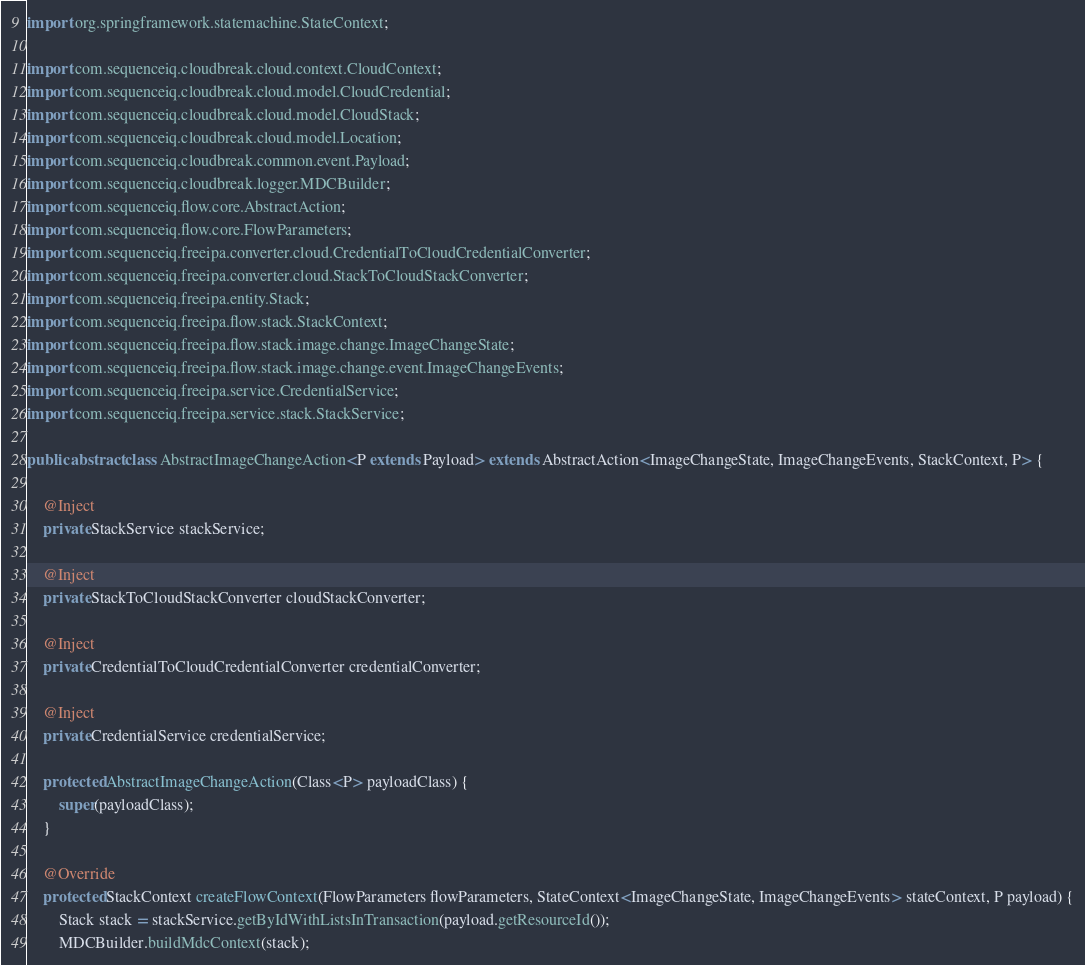<code> <loc_0><loc_0><loc_500><loc_500><_Java_>
import org.springframework.statemachine.StateContext;

import com.sequenceiq.cloudbreak.cloud.context.CloudContext;
import com.sequenceiq.cloudbreak.cloud.model.CloudCredential;
import com.sequenceiq.cloudbreak.cloud.model.CloudStack;
import com.sequenceiq.cloudbreak.cloud.model.Location;
import com.sequenceiq.cloudbreak.common.event.Payload;
import com.sequenceiq.cloudbreak.logger.MDCBuilder;
import com.sequenceiq.flow.core.AbstractAction;
import com.sequenceiq.flow.core.FlowParameters;
import com.sequenceiq.freeipa.converter.cloud.CredentialToCloudCredentialConverter;
import com.sequenceiq.freeipa.converter.cloud.StackToCloudStackConverter;
import com.sequenceiq.freeipa.entity.Stack;
import com.sequenceiq.freeipa.flow.stack.StackContext;
import com.sequenceiq.freeipa.flow.stack.image.change.ImageChangeState;
import com.sequenceiq.freeipa.flow.stack.image.change.event.ImageChangeEvents;
import com.sequenceiq.freeipa.service.CredentialService;
import com.sequenceiq.freeipa.service.stack.StackService;

public abstract class AbstractImageChangeAction<P extends Payload> extends AbstractAction<ImageChangeState, ImageChangeEvents, StackContext, P> {

    @Inject
    private StackService stackService;

    @Inject
    private StackToCloudStackConverter cloudStackConverter;

    @Inject
    private CredentialToCloudCredentialConverter credentialConverter;

    @Inject
    private CredentialService credentialService;

    protected AbstractImageChangeAction(Class<P> payloadClass) {
        super(payloadClass);
    }

    @Override
    protected StackContext createFlowContext(FlowParameters flowParameters, StateContext<ImageChangeState, ImageChangeEvents> stateContext, P payload) {
        Stack stack = stackService.getByIdWithListsInTransaction(payload.getResourceId());
        MDCBuilder.buildMdcContext(stack);</code> 